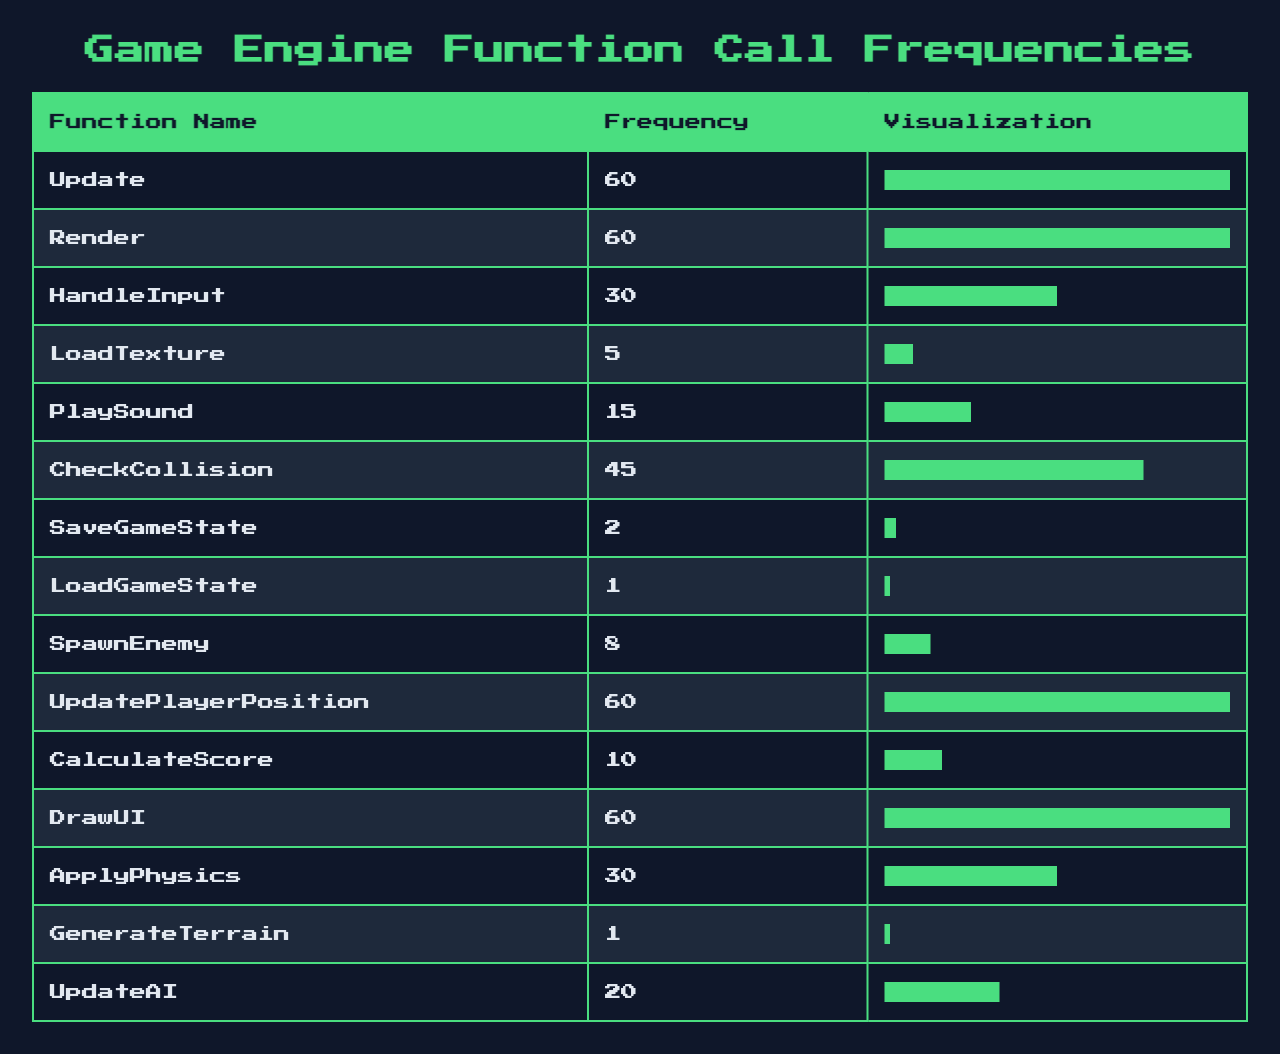What is the frequency of the function "Render"? The table shows that the frequency of the function "Render" is 60.
Answer: 60 Which function has the lowest frequency? Looking at the table, "LoadGameState" has the lowest frequency with a value of 1.
Answer: LoadGameState What is the total frequency of functions "LoadTexture," "PlaySound," and "SpawnEnemy"? The total frequency can be calculated: 5 (LoadTexture) + 15 (PlaySound) + 8 (SpawnEnemy) = 28.
Answer: 28 How many functions have a frequency greater than 40? Analyzing the table, the functions "Update," "Render," "CheckCollision," "UpdatePlayerPosition," and "DrawUI" all exceed a frequency of 40. This makes a total of 5 functions.
Answer: 5 What percentage of the max frequency is the frequency of "HandleInput"? The max frequency is 60, so for "HandleInput" with a frequency of 30: (30/60) * 100 = 50%.
Answer: 50% Is there a function that has the same frequency as "UpdatePlayerPosition"? Yes, "Update," and "DrawUI" both have a frequency of 60, which matches that of "UpdatePlayerPosition."
Answer: Yes What is the average frequency of all functions listed in the table? To calculate the average, sum the frequencies: 60 + 60 + 30 + 5 + 15 + 45 + 2 + 1 + 8 + 60 + 10 + 60 + 30 + 1 + 20 = 337, and divide by the number of functions (15): 337 / 15 = 22.47.
Answer: 22.47 If you sum the frequencies of all the functions that deal with input handling, what would the result be? The relevant functions are "HandleInput" (30). No other function specifically deals with input handling, so the sum is simply 30.
Answer: 30 How many functions are called exactly 60 times? In the table, "Update," "Render," "UpdatePlayerPosition," and "DrawUI" all have a frequency of 60. Therefore, there are 4 functions.
Answer: 4 What is the combined frequency of functions that have a frequency less than 10? The functions "LoadGameState" (1), "GenerateTerrain" (1), "SaveGameState" (2), and "SpawnEnemy" (8) have frequencies less than 10. So, the sum is 1 + 1 + 2 + 8 = 12.
Answer: 12 